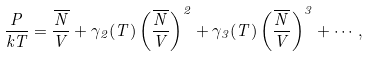Convert formula to latex. <formula><loc_0><loc_0><loc_500><loc_500>\frac { P } { k T } = \frac { \overline { N } } { V } + \gamma _ { 2 } ( T ) \left ( \frac { \overline { N } } { V } \right ) ^ { 2 } + \gamma _ { 3 } ( T ) \left ( \frac { \overline { N } } { V } \right ) ^ { 3 } + \cdots ,</formula> 